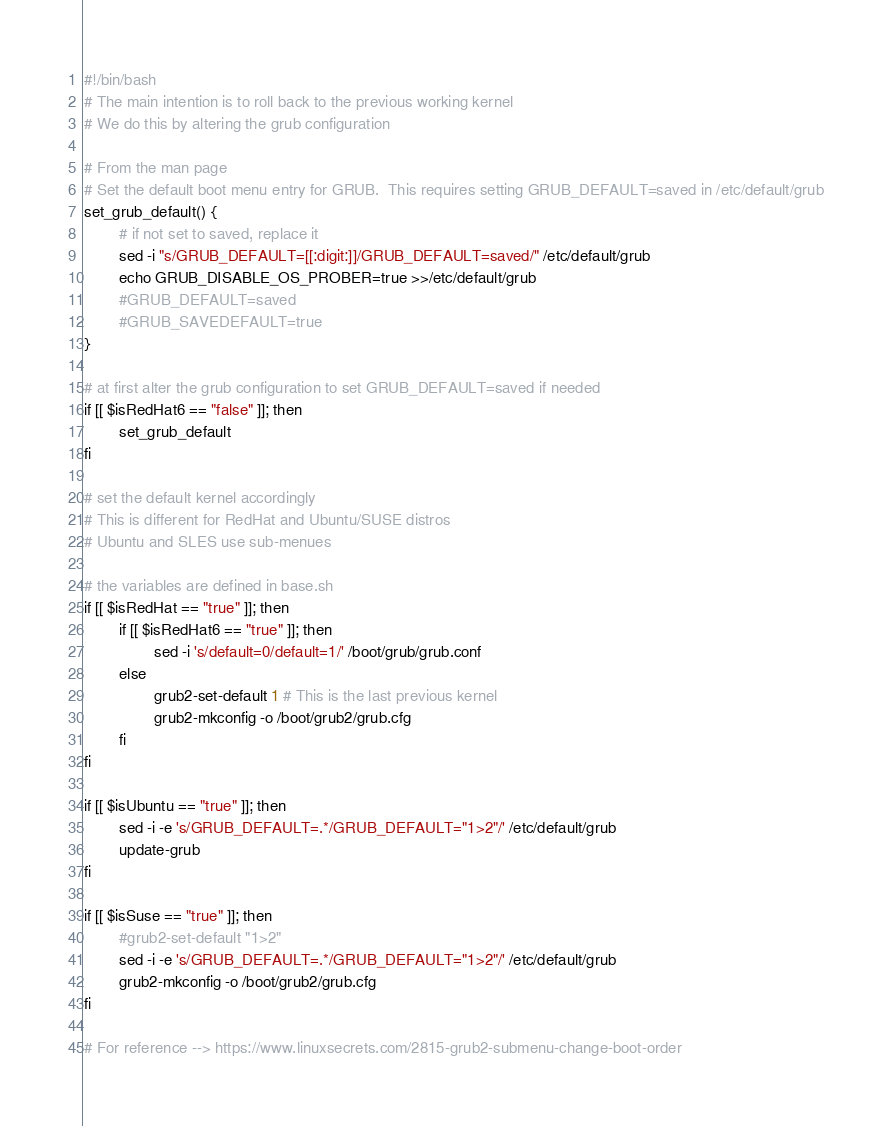Convert code to text. <code><loc_0><loc_0><loc_500><loc_500><_Bash_>#!/bin/bash
# The main intention is to roll back to the previous working kernel
# We do this by altering the grub configuration

# From the man page
# Set the default boot menu entry for GRUB.  This requires setting GRUB_DEFAULT=saved in /etc/default/grub
set_grub_default() {
        # if not set to saved, replace it
        sed -i "s/GRUB_DEFAULT=[[:digit:]]/GRUB_DEFAULT=saved/" /etc/default/grub
        echo GRUB_DISABLE_OS_PROBER=true >>/etc/default/grub
        #GRUB_DEFAULT=saved
        #GRUB_SAVEDEFAULT=true
}

# at first alter the grub configuration to set GRUB_DEFAULT=saved if needed
if [[ $isRedHat6 == "false" ]]; then
        set_grub_default
fi

# set the default kernel accordingly
# This is different for RedHat and Ubuntu/SUSE distros
# Ubuntu and SLES use sub-menues

# the variables are defined in base.sh
if [[ $isRedHat == "true" ]]; then
        if [[ $isRedHat6 == "true" ]]; then
                sed -i 's/default=0/default=1/' /boot/grub/grub.conf
        else
                grub2-set-default 1 # This is the last previous kernel
                grub2-mkconfig -o /boot/grub2/grub.cfg
        fi
fi

if [[ $isUbuntu == "true" ]]; then
        sed -i -e 's/GRUB_DEFAULT=.*/GRUB_DEFAULT="1>2"/' /etc/default/grub
        update-grub
fi

if [[ $isSuse == "true" ]]; then
        #grub2-set-default "1>2"
        sed -i -e 's/GRUB_DEFAULT=.*/GRUB_DEFAULT="1>2"/' /etc/default/grub
        grub2-mkconfig -o /boot/grub2/grub.cfg
fi

# For reference --> https://www.linuxsecrets.com/2815-grub2-submenu-change-boot-order

</code> 